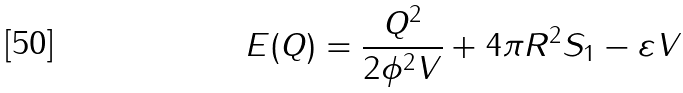Convert formula to latex. <formula><loc_0><loc_0><loc_500><loc_500>E ( Q ) = \frac { Q ^ { 2 } } { 2 \phi ^ { 2 } V } + 4 \pi R ^ { 2 } S _ { 1 } - \varepsilon V</formula> 